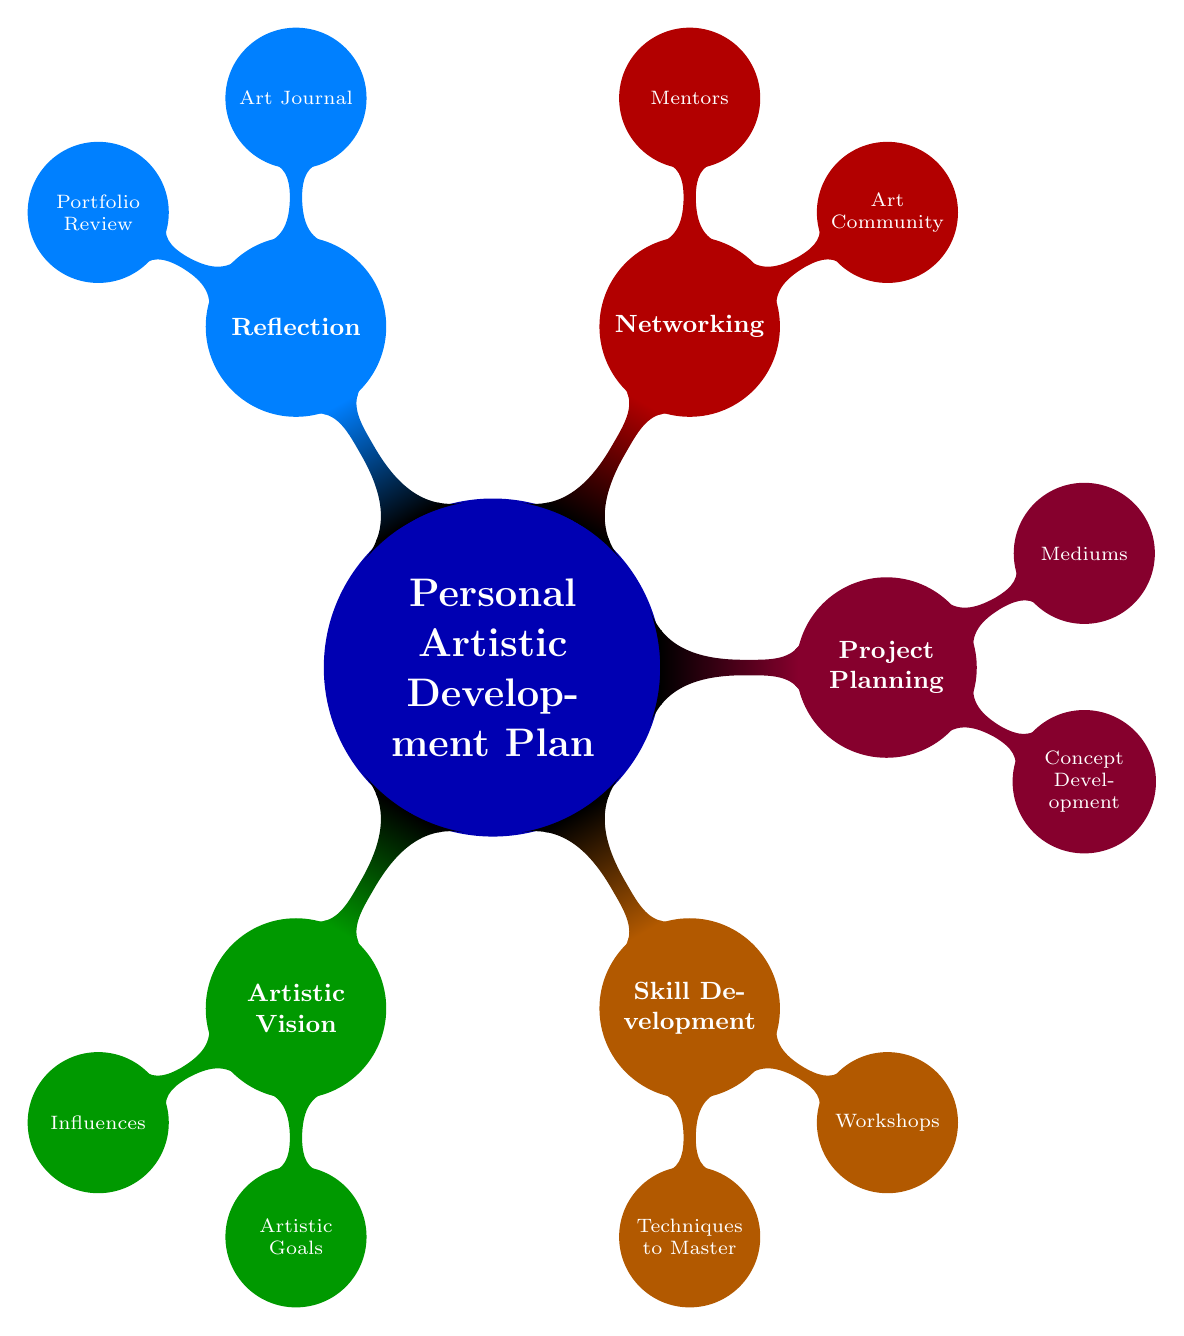What is the main topic of the mind map? The central node of the mind map states "Personal Artistic Development Plan," which indicates the primary focus of the entire diagram.
Answer: Personal Artistic Development Plan How many main branches are there in the diagram? There are five main branches stemming from the root concept, each representing different aspects of the artistic development plan: Artistic Vision, Skill Development, Project Planning, Networking, and Reflection.
Answer: 5 What are the two subcategories under Artistic Vision? The subcategories under Artistic Vision are "Influences" and "Artistic Goals," which detail different components of an artistic vision.
Answer: Influences, Artistic Goals Which branch focuses on community and support? The Networking branch addresses the aspects related to community and support, including connections within the art community and mentoring opportunities.
Answer: Networking What is one technique to master listed in the Skill Development branch? One specific technique to master mentioned under Skill Development is "Color Theory," which highlights a crucial area of knowledge for an artist.
Answer: Color Theory What type of workshops are suggested under Skill Development? The workshops suggested include "Online Op Art Courses," indicating a focus on contemporary art techniques in an accessible format.
Answer: Online Op Art Courses How many components are listed under Project Planning? There are two main components under Project Planning: "Concept Development" and "Mediums," which outline important aspects of planning artistic projects.
Answer: 2 What does the Reflection branch include for monitoring progress? The Reflection branch includes an "Art Journal," which serves as a tool for monitoring and reflecting on ongoing artistic progress.
Answer: Art Journal Which specific influences are mentioned in the Artistic Vision? The influences listed in the Artistic Vision include "Bridget Riley," "Piet Mondrian," and "Yayoi Kusama," emphasizing a modern art influence.
Answer: Bridget Riley, Piet Mondrian, Yayoi Kusama 